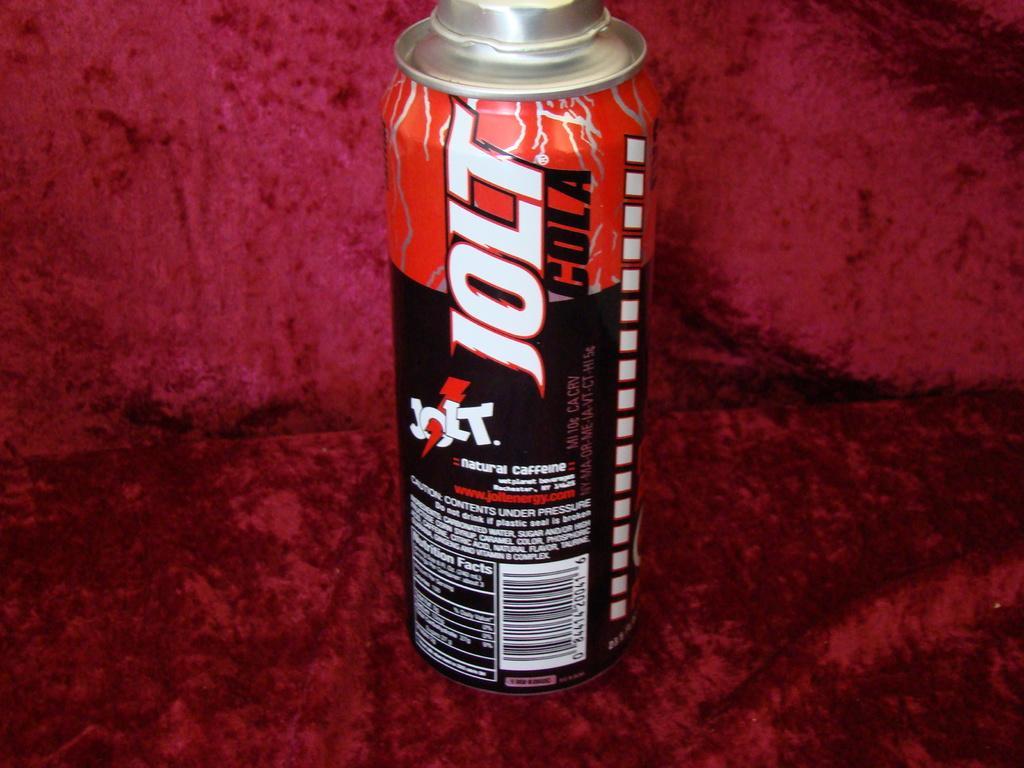What type of drink is this?
Make the answer very short. Jolt cola. Are there nutritional facts visible on this can?
Provide a succinct answer. Yes. Whats the name on this can?
Make the answer very short. Jolt cola. 